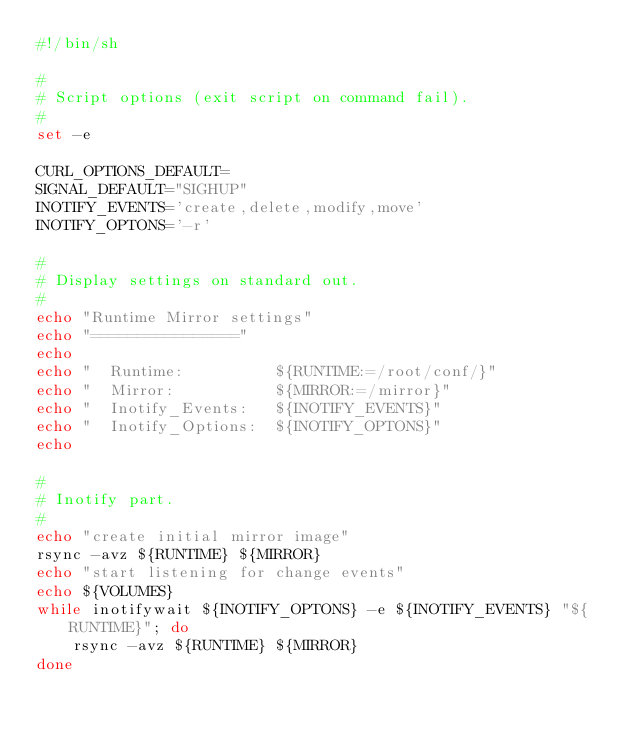Convert code to text. <code><loc_0><loc_0><loc_500><loc_500><_Bash_>#!/bin/sh

#
# Script options (exit script on command fail).
#
set -e

CURL_OPTIONS_DEFAULT=
SIGNAL_DEFAULT="SIGHUP"
INOTIFY_EVENTS='create,delete,modify,move'
INOTIFY_OPTONS='-r'

#
# Display settings on standard out.
#
echo "Runtime Mirror settings"
echo "================"
echo
echo "  Runtime:          ${RUNTIME:=/root/conf/}"
echo "  Mirror:           ${MIRROR:=/mirror}"
echo "  Inotify_Events:   ${INOTIFY_EVENTS}"
echo "  Inotify_Options:  ${INOTIFY_OPTONS}"
echo

#
# Inotify part.
#
echo "create initial mirror image"
rsync -avz ${RUNTIME} ${MIRROR}
echo "start listening for change events"
echo ${VOLUMES}
while inotifywait ${INOTIFY_OPTONS} -e ${INOTIFY_EVENTS} "${RUNTIME}"; do
    rsync -avz ${RUNTIME} ${MIRROR}
done</code> 